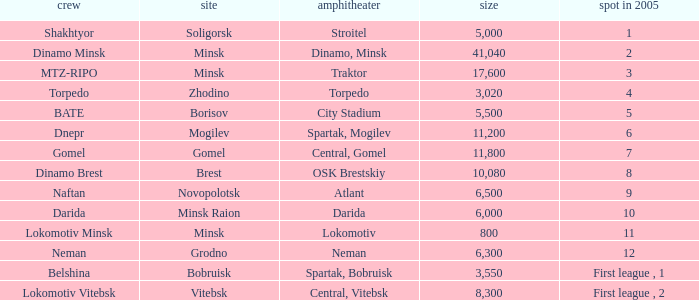Can you tell me the Venue that has the Position in 2005 of 8? OSK Brestskiy. 